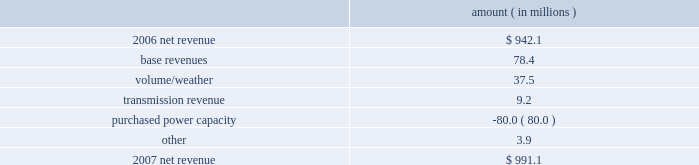Entergy louisiana , llc management's financial discussion and analysis 2007 compared to 2006 net revenue consists of operating revenues net of : 1 ) fuel , fuel-related expenses , and gas purchased for resale , 2 ) purchased power expenses , and 3 ) other regulatory charges ( credits ) .
Following is an analysis of the change in net revenue comparing 2007 to 2006 .
Amount ( in millions ) .
The base revenues variance is primarily due to increases effective september 2006 for the 2005 formula rate plan filing to recover lpsc-approved incremental deferred and ongoing capacity costs .
See "state and local rate regulation" below and note 2 to the financial statements for a discussion of the formula rate plan filing .
The volume/weather variance is due to increased electricity usage , including electricity sales during the unbilled service period .
Billed retail electricity usage increased a total of 666 gwh in all sectors compared to 2006 .
See "critical accounting estimates" below and note 1 to the financial statements for further discussion of the accounting for unbilled revenues .
The transmission revenue variance is primarily due to higher rates .
The purchased power capacity variance is primarily due to higher purchased power capacity charges and the amortization of capacity charges effective september 2006 as a result of the formula rate plan filing in may 2006 .
A portion of the purchased power capacity costs is offset in base revenues due to a base rate increase implemented to recover incremental deferred and ongoing purchased power capacity charges , as mentioned above .
See "state and local rate regulation" below and note 2 to the financial statements for a discussion of the formula rate plan filing .
Gross operating revenues , fuel , purchased power expenses , and other regulatory charges ( credits ) gross operating revenues increased primarily due to : an increase of $ 143.1 million in fuel cost recovery revenues due to higher fuel rates and usage ; an increase of $ 78.4 million in base revenues , as discussed above ; and an increase of $ 37.5 million related to volume/weather , as discussed above .
Fuel and purchased power expenses increased primarily due to an increase in net area demand and an increase in deferred fuel expense as a result of higher fuel rates , as discussed above .
Other regulatory credits decreased primarily due to the deferral of capacity charges in 2006 in addition to the amortization of these capacity charges in 2007 as a result of the may 2006 formula rate plan filing ( for the 2005 test year ) with the lpsc to recover such costs through base rates effective september 2006 .
See note 2 to the financial statements for a discussion of the formula rate plan and storm cost recovery filings with the lpsc. .
What is the net change in net revenue during 2007? 
Computations: (991.1 - 942.1)
Answer: 49.0. 